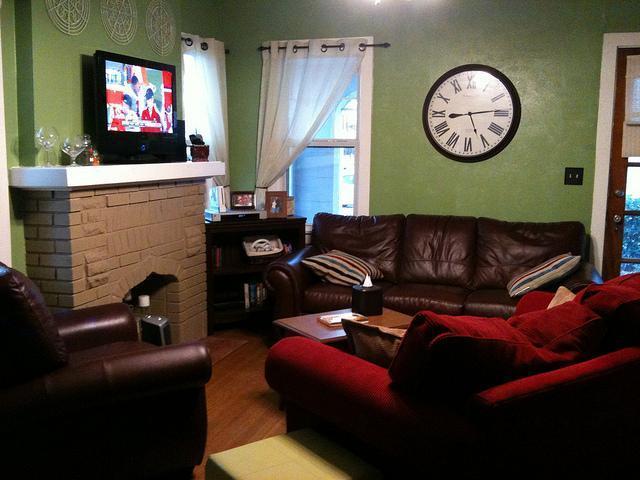How many couches are there?
Give a very brief answer. 3. 